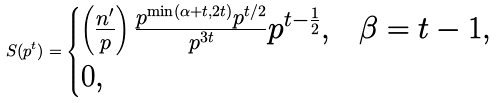<formula> <loc_0><loc_0><loc_500><loc_500>S ( p ^ { t } ) = \begin{cases} \left ( \frac { n ^ { \prime } } { p } \right ) \frac { p ^ { \min ( \alpha + t , 2 t ) } p ^ { t / 2 } } { p ^ { 3 t } } p ^ { t - \frac { 1 } { 2 } } , & \beta = t - 1 , \\ 0 , & \end{cases}</formula> 